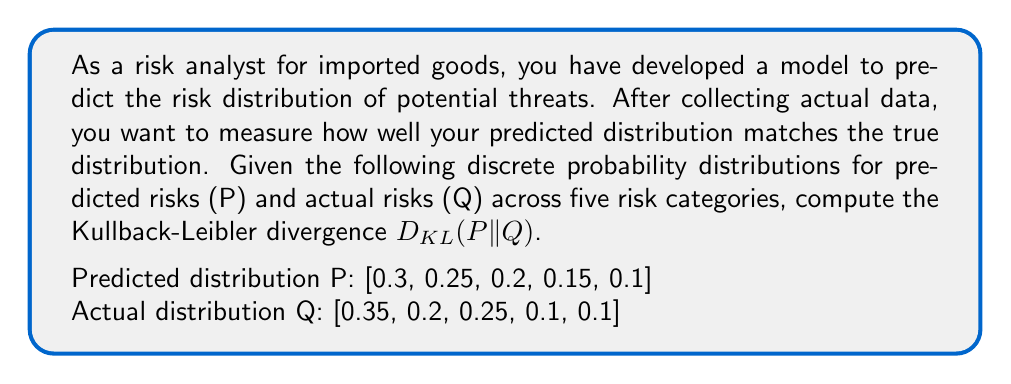What is the answer to this math problem? The Kullback-Leibler divergence $D_{KL}(P||Q)$ measures the relative entropy between two probability distributions P and Q. It quantifies the information lost when Q is used to approximate P. For discrete probability distributions, the formula is:

$$D_{KL}(P||Q) = \sum_{i} P(i) \log \left(\frac{P(i)}{Q(i)}\right)$$

Where $P(i)$ and $Q(i)$ are the probabilities of event i in distributions P and Q, respectively.

Let's calculate this step-by-step:

1) For each risk category i, we need to calculate $P(i) \log \left(\frac{P(i)}{Q(i)}\right)$:

   i = 1: $0.3 \log(\frac{0.3}{0.35}) = 0.3 \log(0.8571) = -0.0457$
   i = 2: $0.25 \log(\frac{0.25}{0.2}) = 0.25 \log(1.25) = 0.0558$
   i = 3: $0.2 \log(\frac{0.2}{0.25}) = 0.2 \log(0.8) = -0.0458$
   i = 4: $0.15 \log(\frac{0.15}{0.1}) = 0.15 \log(1.5) = 0.0608$
   i = 5: $0.1 \log(\frac{0.1}{0.1}) = 0.1 \log(1) = 0$

2) Sum up all these values:

   $D_{KL}(P||Q) = (-0.0457) + 0.0558 + (-0.0458) + 0.0608 + 0 = 0.0251$

Therefore, the Kullback-Leibler divergence between the predicted and actual risk distributions is approximately 0.0251 bits.
Answer: $D_{KL}(P||Q) \approx 0.0251$ bits 